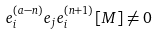<formula> <loc_0><loc_0><loc_500><loc_500>e _ { i } ^ { ( a - n ) } e _ { j } e _ { i } ^ { ( n + 1 ) } [ M ] \neq 0</formula> 